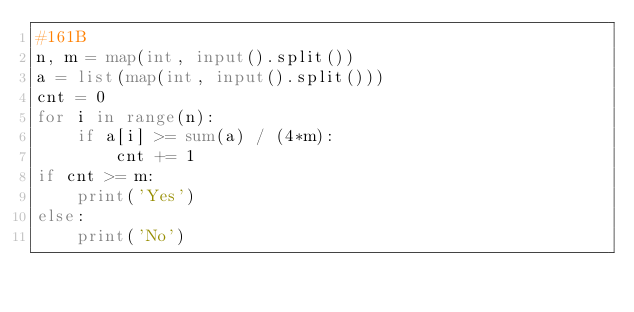<code> <loc_0><loc_0><loc_500><loc_500><_Python_>#161B
n, m = map(int, input().split())
a = list(map(int, input().split()))
cnt = 0
for i in range(n):
    if a[i] >= sum(a) / (4*m):
        cnt += 1
if cnt >= m:
    print('Yes')
else:
    print('No')</code> 